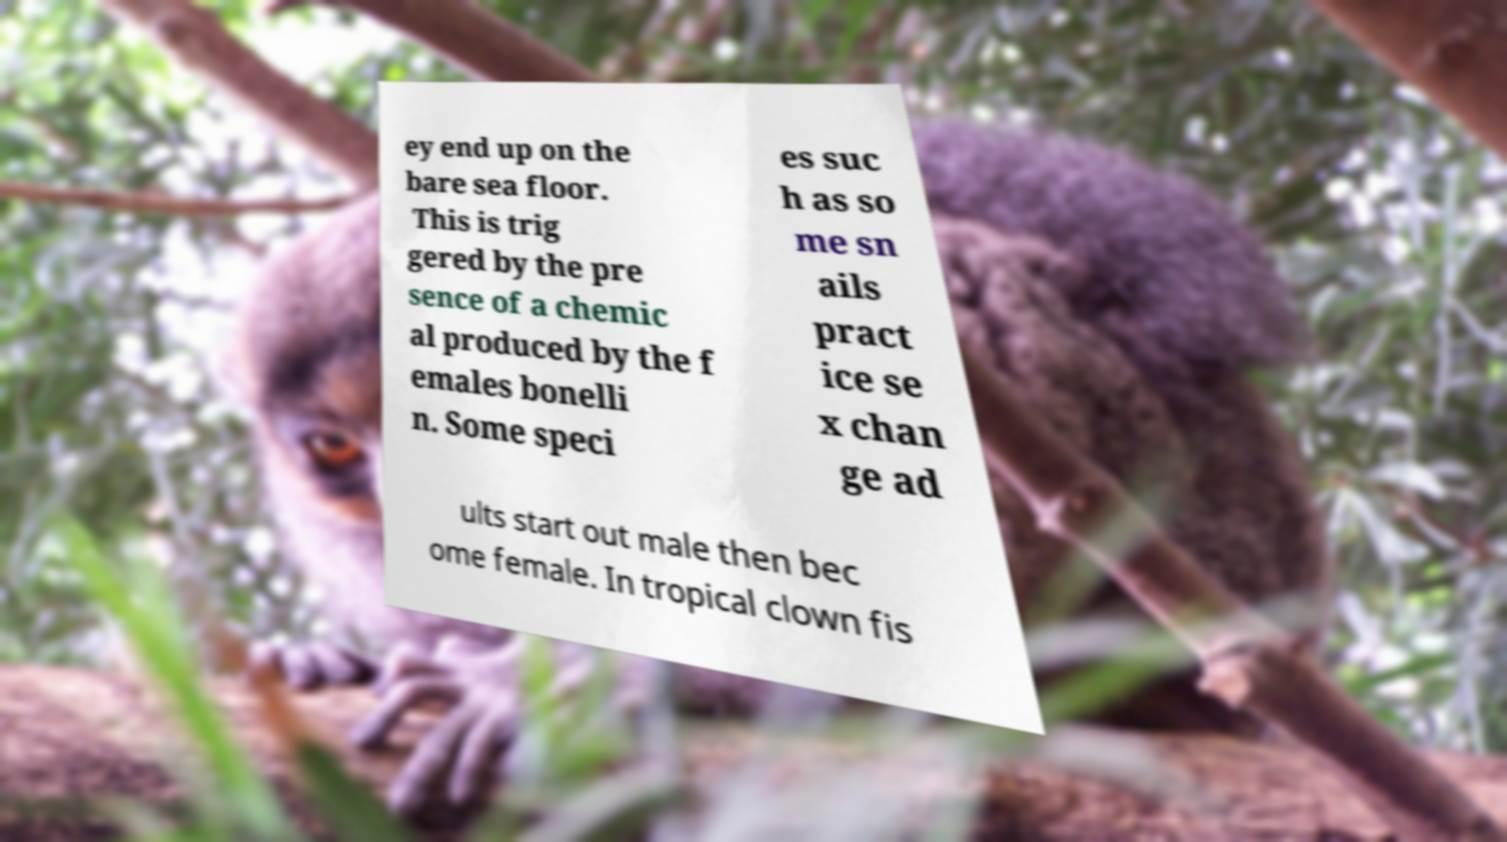Can you accurately transcribe the text from the provided image for me? ey end up on the bare sea floor. This is trig gered by the pre sence of a chemic al produced by the f emales bonelli n. Some speci es suc h as so me sn ails pract ice se x chan ge ad ults start out male then bec ome female. In tropical clown fis 